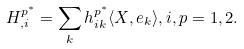Convert formula to latex. <formula><loc_0><loc_0><loc_500><loc_500>H ^ { p ^ { \ast } } _ { , i } = \sum _ { k } h ^ { p ^ { \ast } } _ { i k } \langle X , e _ { k } \rangle , i , p = 1 , 2 .</formula> 